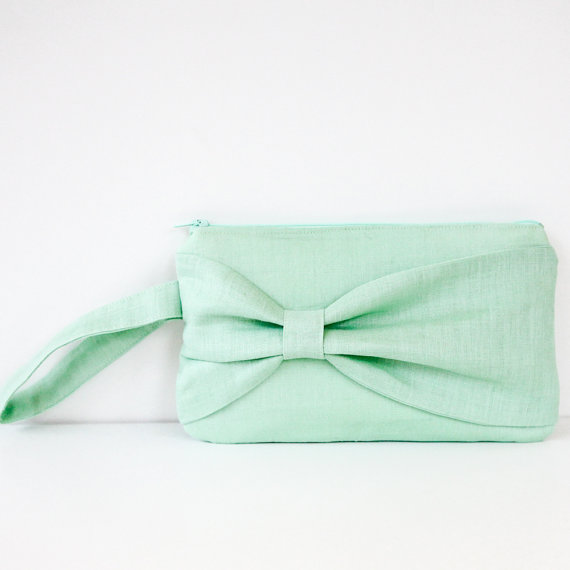What materials might this clutch purse be made of, and what does that imply about its durability and maintenance? The clutch purse appears to be made of a soft, woven fabric, possibly linen or a high-quality cotton blend. This choice of material suggests that the purse is relatively lightweight and breathable, ideal for warm weather. While these fabrics are generally durable, they do require some care to maintain their pristine appearance. Spot cleaning and gentle hand washing are advised to preserve the fabric's integrity and prevent any damage. The material also implies a casual yet elegant look, matching well with semi-formal attire. 